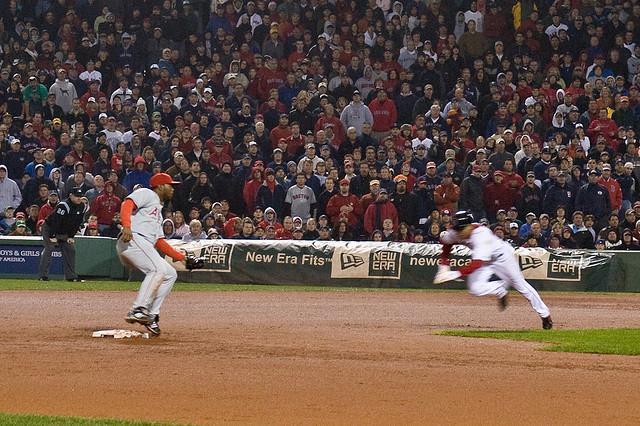How many people can you see?
Give a very brief answer. 3. 